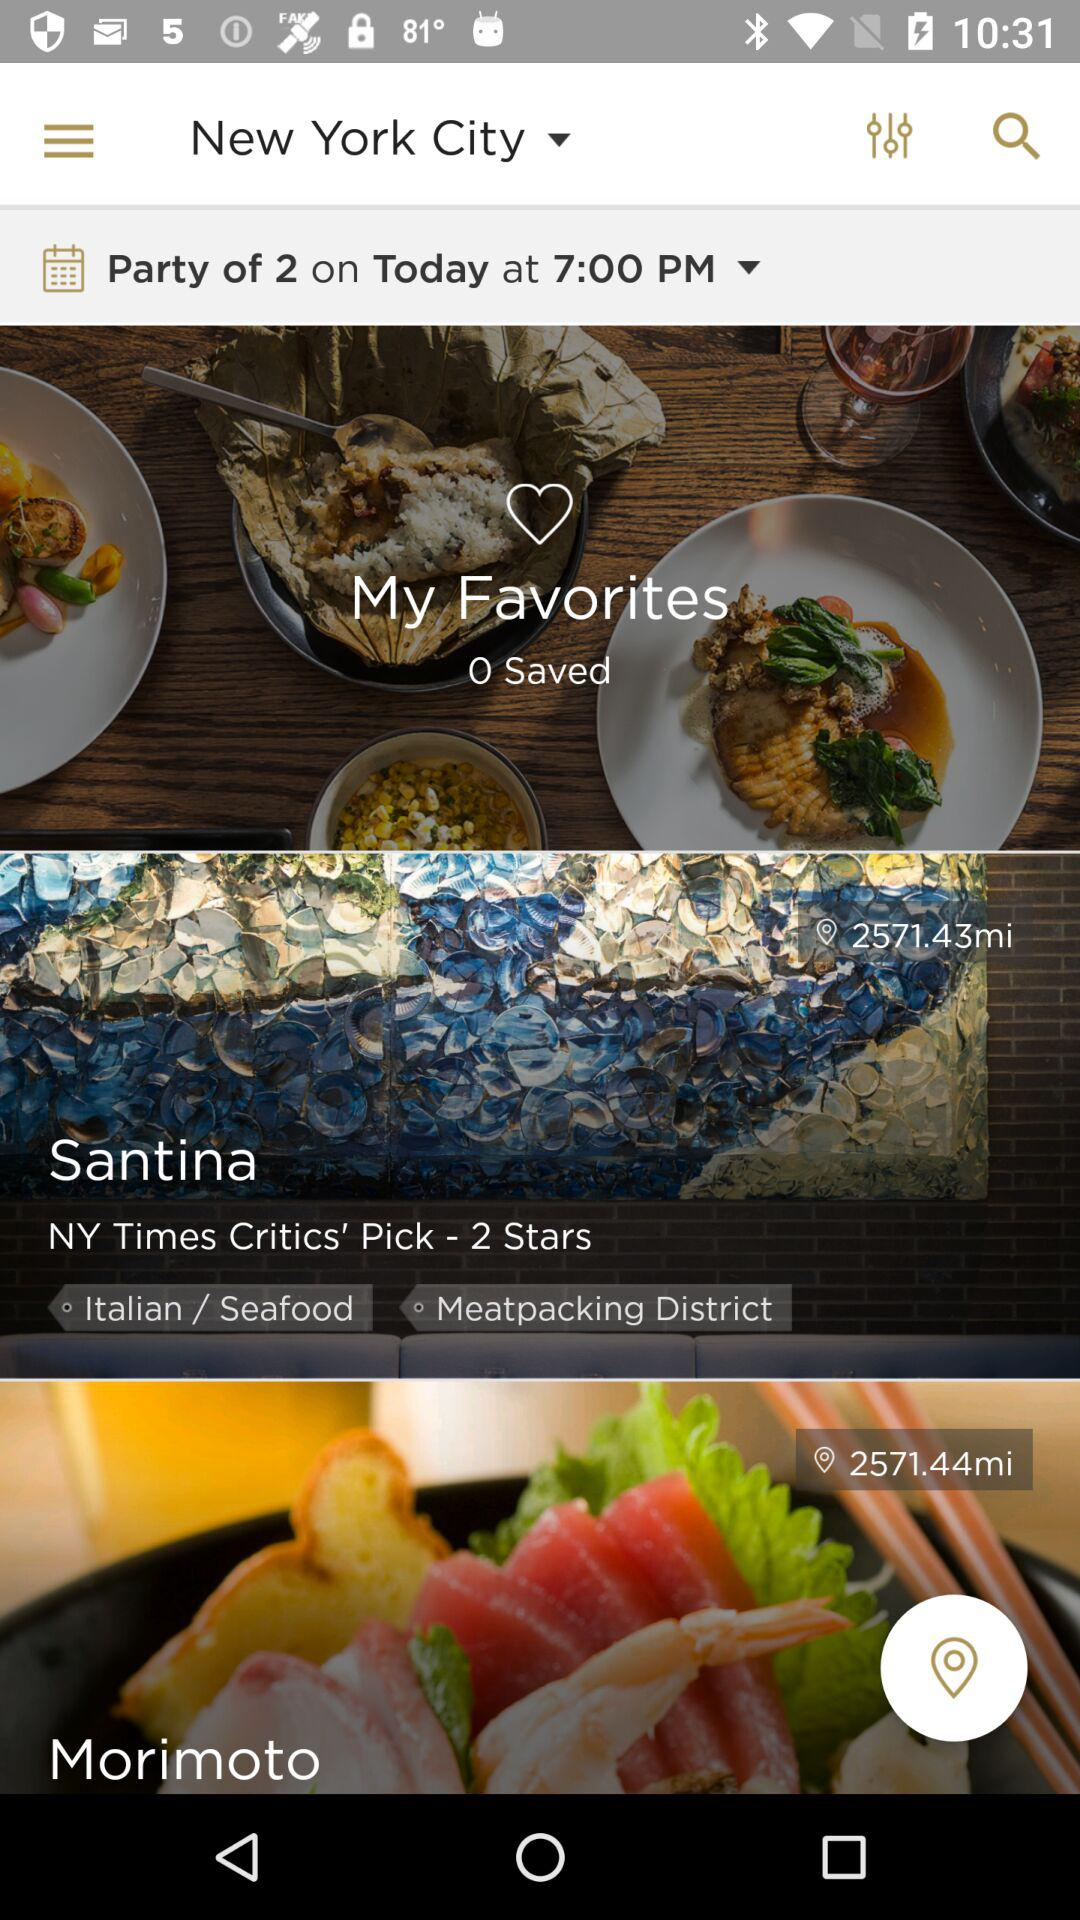What type of food did Santina have? Santina has "Italian / Seafood". 